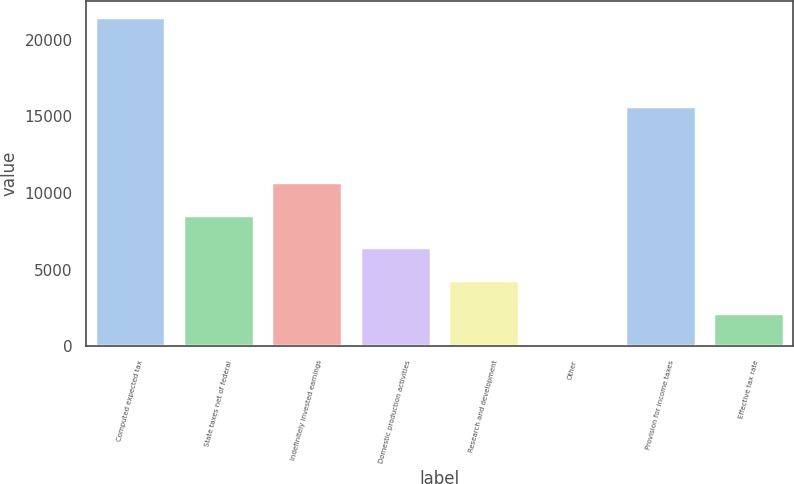Convert chart. <chart><loc_0><loc_0><loc_500><loc_500><bar_chart><fcel>Computed expected tax<fcel>State taxes net of federal<fcel>Indefinitely invested earnings<fcel>Domestic production activities<fcel>Research and development<fcel>Other<fcel>Provision for income taxes<fcel>Effective tax rate<nl><fcel>21480<fcel>8599.8<fcel>10746.5<fcel>6453.1<fcel>4306.4<fcel>13<fcel>15685<fcel>2159.7<nl></chart> 